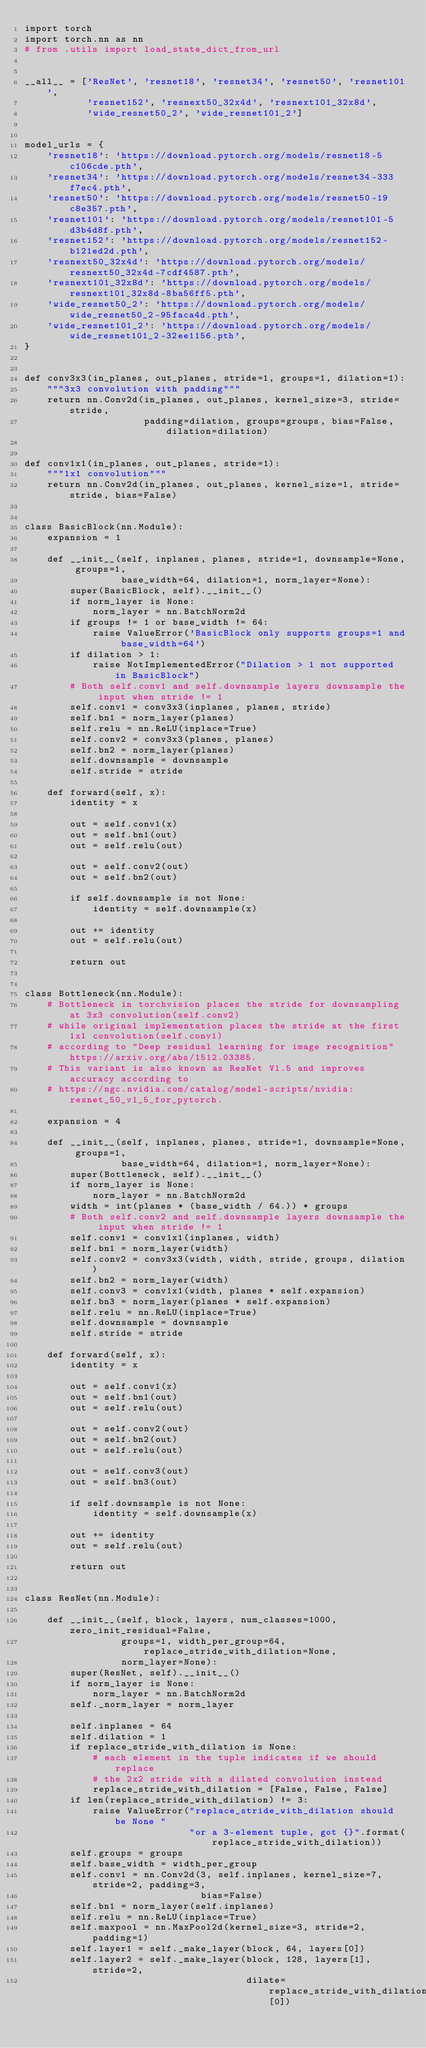Convert code to text. <code><loc_0><loc_0><loc_500><loc_500><_Python_>import torch
import torch.nn as nn
# from .utils import load_state_dict_from_url


__all__ = ['ResNet', 'resnet18', 'resnet34', 'resnet50', 'resnet101',
           'resnet152', 'resnext50_32x4d', 'resnext101_32x8d',
           'wide_resnet50_2', 'wide_resnet101_2']


model_urls = {
    'resnet18': 'https://download.pytorch.org/models/resnet18-5c106cde.pth',
    'resnet34': 'https://download.pytorch.org/models/resnet34-333f7ec4.pth',
    'resnet50': 'https://download.pytorch.org/models/resnet50-19c8e357.pth',
    'resnet101': 'https://download.pytorch.org/models/resnet101-5d3b4d8f.pth',
    'resnet152': 'https://download.pytorch.org/models/resnet152-b121ed2d.pth',
    'resnext50_32x4d': 'https://download.pytorch.org/models/resnext50_32x4d-7cdf4587.pth',
    'resnext101_32x8d': 'https://download.pytorch.org/models/resnext101_32x8d-8ba56ff5.pth',
    'wide_resnet50_2': 'https://download.pytorch.org/models/wide_resnet50_2-95faca4d.pth',
    'wide_resnet101_2': 'https://download.pytorch.org/models/wide_resnet101_2-32ee1156.pth',
}


def conv3x3(in_planes, out_planes, stride=1, groups=1, dilation=1):
    """3x3 convolution with padding"""
    return nn.Conv2d(in_planes, out_planes, kernel_size=3, stride=stride,
                     padding=dilation, groups=groups, bias=False, dilation=dilation)


def conv1x1(in_planes, out_planes, stride=1):
    """1x1 convolution"""
    return nn.Conv2d(in_planes, out_planes, kernel_size=1, stride=stride, bias=False)


class BasicBlock(nn.Module):
    expansion = 1

    def __init__(self, inplanes, planes, stride=1, downsample=None, groups=1,
                 base_width=64, dilation=1, norm_layer=None):
        super(BasicBlock, self).__init__()
        if norm_layer is None:
            norm_layer = nn.BatchNorm2d
        if groups != 1 or base_width != 64:
            raise ValueError('BasicBlock only supports groups=1 and base_width=64')
        if dilation > 1:
            raise NotImplementedError("Dilation > 1 not supported in BasicBlock")
        # Both self.conv1 and self.downsample layers downsample the input when stride != 1
        self.conv1 = conv3x3(inplanes, planes, stride)
        self.bn1 = norm_layer(planes)
        self.relu = nn.ReLU(inplace=True)
        self.conv2 = conv3x3(planes, planes)
        self.bn2 = norm_layer(planes)
        self.downsample = downsample
        self.stride = stride

    def forward(self, x):
        identity = x

        out = self.conv1(x)
        out = self.bn1(out)
        out = self.relu(out)

        out = self.conv2(out)
        out = self.bn2(out)

        if self.downsample is not None:
            identity = self.downsample(x)

        out += identity
        out = self.relu(out)

        return out


class Bottleneck(nn.Module):
    # Bottleneck in torchvision places the stride for downsampling at 3x3 convolution(self.conv2)
    # while original implementation places the stride at the first 1x1 convolution(self.conv1)
    # according to "Deep residual learning for image recognition"https://arxiv.org/abs/1512.03385.
    # This variant is also known as ResNet V1.5 and improves accuracy according to
    # https://ngc.nvidia.com/catalog/model-scripts/nvidia:resnet_50_v1_5_for_pytorch.

    expansion = 4

    def __init__(self, inplanes, planes, stride=1, downsample=None, groups=1,
                 base_width=64, dilation=1, norm_layer=None):
        super(Bottleneck, self).__init__()
        if norm_layer is None:
            norm_layer = nn.BatchNorm2d
        width = int(planes * (base_width / 64.)) * groups
        # Both self.conv2 and self.downsample layers downsample the input when stride != 1
        self.conv1 = conv1x1(inplanes, width)
        self.bn1 = norm_layer(width)
        self.conv2 = conv3x3(width, width, stride, groups, dilation)
        self.bn2 = norm_layer(width)
        self.conv3 = conv1x1(width, planes * self.expansion)
        self.bn3 = norm_layer(planes * self.expansion)
        self.relu = nn.ReLU(inplace=True)
        self.downsample = downsample
        self.stride = stride

    def forward(self, x):
        identity = x

        out = self.conv1(x)
        out = self.bn1(out)
        out = self.relu(out)

        out = self.conv2(out)
        out = self.bn2(out)
        out = self.relu(out)

        out = self.conv3(out)
        out = self.bn3(out)

        if self.downsample is not None:
            identity = self.downsample(x)

        out += identity
        out = self.relu(out)

        return out


class ResNet(nn.Module):

    def __init__(self, block, layers, num_classes=1000, zero_init_residual=False,
                 groups=1, width_per_group=64, replace_stride_with_dilation=None,
                 norm_layer=None):
        super(ResNet, self).__init__()
        if norm_layer is None:
            norm_layer = nn.BatchNorm2d
        self._norm_layer = norm_layer

        self.inplanes = 64
        self.dilation = 1
        if replace_stride_with_dilation is None:
            # each element in the tuple indicates if we should replace
            # the 2x2 stride with a dilated convolution instead
            replace_stride_with_dilation = [False, False, False]
        if len(replace_stride_with_dilation) != 3:
            raise ValueError("replace_stride_with_dilation should be None "
                             "or a 3-element tuple, got {}".format(replace_stride_with_dilation))
        self.groups = groups
        self.base_width = width_per_group
        self.conv1 = nn.Conv2d(3, self.inplanes, kernel_size=7, stride=2, padding=3,
                               bias=False)
        self.bn1 = norm_layer(self.inplanes)
        self.relu = nn.ReLU(inplace=True)
        self.maxpool = nn.MaxPool2d(kernel_size=3, stride=2, padding=1)
        self.layer1 = self._make_layer(block, 64, layers[0])
        self.layer2 = self._make_layer(block, 128, layers[1], stride=2,
                                       dilate=replace_stride_with_dilation[0])</code> 